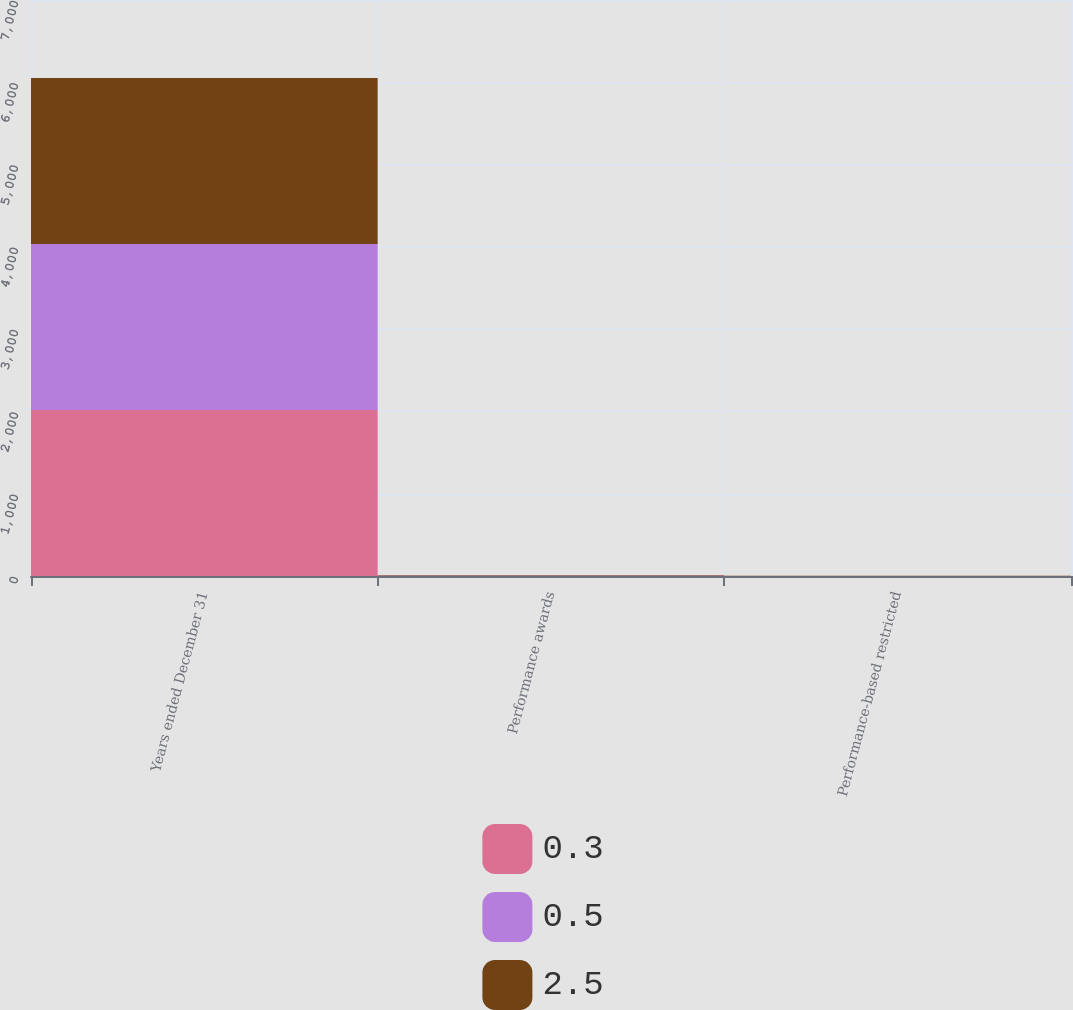Convert chart to OTSL. <chart><loc_0><loc_0><loc_500><loc_500><stacked_bar_chart><ecel><fcel>Years ended December 31<fcel>Performance awards<fcel>Performance-based restricted<nl><fcel>0.3<fcel>2018<fcel>2.5<fcel>0.3<nl><fcel>0.5<fcel>2017<fcel>4.1<fcel>0.5<nl><fcel>2.5<fcel>2016<fcel>6.5<fcel>2.5<nl></chart> 